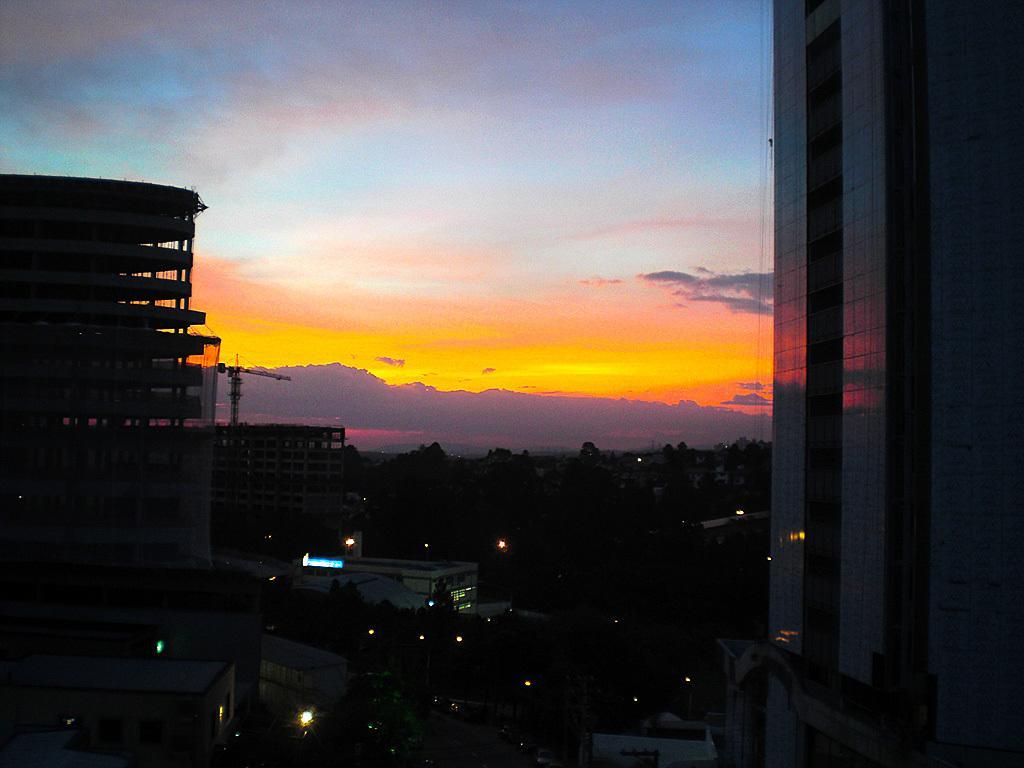Describe this image in one or two sentences. In this image I can see few buildings and I can also see few lights. Background the sky is in orange, blue and white color. 